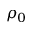<formula> <loc_0><loc_0><loc_500><loc_500>\rho _ { 0 }</formula> 